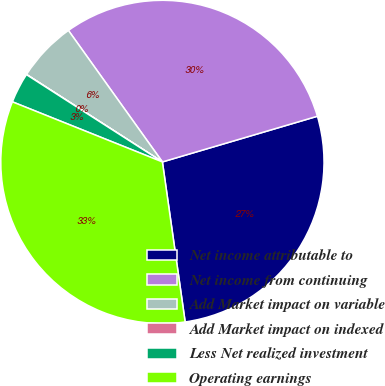Convert chart. <chart><loc_0><loc_0><loc_500><loc_500><pie_chart><fcel>Net income attributable to<fcel>Net income from continuing<fcel>Add Market impact on variable<fcel>Add Market impact on indexed<fcel>Less Net realized investment<fcel>Operating earnings<nl><fcel>27.32%<fcel>30.32%<fcel>6.02%<fcel>0.02%<fcel>3.02%<fcel>33.32%<nl></chart> 